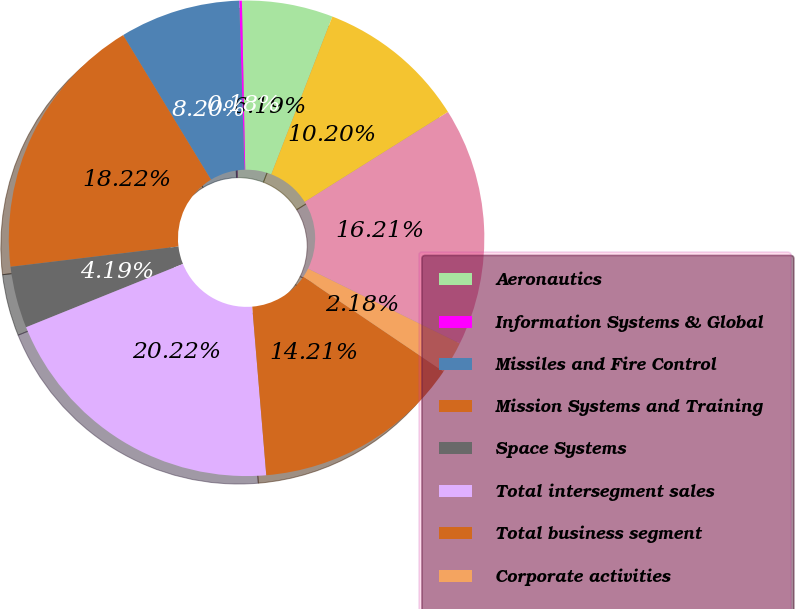Convert chart to OTSL. <chart><loc_0><loc_0><loc_500><loc_500><pie_chart><fcel>Aeronautics<fcel>Information Systems & Global<fcel>Missiles and Fire Control<fcel>Mission Systems and Training<fcel>Space Systems<fcel>Total intersegment sales<fcel>Total business segment<fcel>Corporate activities<fcel>Total depreciation and<fcel>Total business segment capital<nl><fcel>6.19%<fcel>0.18%<fcel>8.2%<fcel>18.22%<fcel>4.19%<fcel>20.22%<fcel>14.21%<fcel>2.18%<fcel>16.21%<fcel>10.2%<nl></chart> 